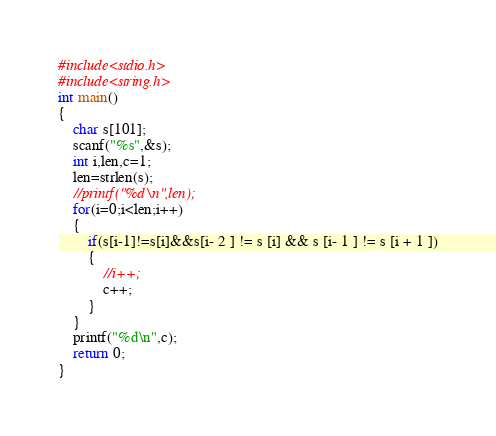Convert code to text. <code><loc_0><loc_0><loc_500><loc_500><_C_>#include<stdio.h>
#include<string.h>
int main()
{
    char s[101];
    scanf("%s",&s);
    int i,len,c=1;
    len=strlen(s);
    //printf("%d\n",len);
    for(i=0;i<len;i++)
    {
        if(s[i-1]!=s[i]&&s[i- 2 ] != s [i] && s [i- 1 ] != s [i + 1 ])
        {
            //i++;
            c++;
        }
    }
    printf("%d\n",c);
    return 0;
}
</code> 